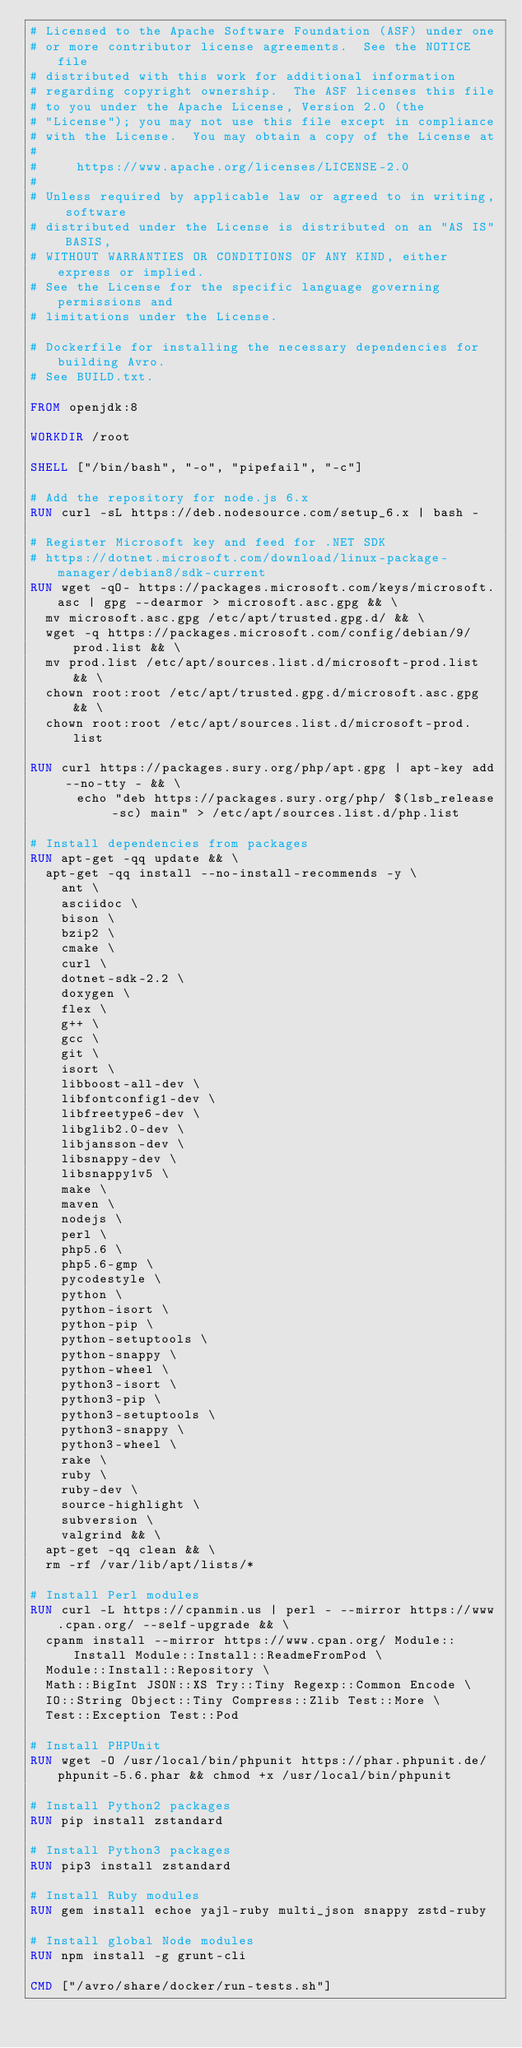<code> <loc_0><loc_0><loc_500><loc_500><_Dockerfile_># Licensed to the Apache Software Foundation (ASF) under one
# or more contributor license agreements.  See the NOTICE file
# distributed with this work for additional information
# regarding copyright ownership.  The ASF licenses this file
# to you under the Apache License, Version 2.0 (the
# "License"); you may not use this file except in compliance
# with the License.  You may obtain a copy of the License at
#
#     https://www.apache.org/licenses/LICENSE-2.0
#
# Unless required by applicable law or agreed to in writing, software
# distributed under the License is distributed on an "AS IS" BASIS,
# WITHOUT WARRANTIES OR CONDITIONS OF ANY KIND, either express or implied.
# See the License for the specific language governing permissions and
# limitations under the License.

# Dockerfile for installing the necessary dependencies for building Avro.
# See BUILD.txt.

FROM openjdk:8

WORKDIR /root

SHELL ["/bin/bash", "-o", "pipefail", "-c"]

# Add the repository for node.js 6.x
RUN curl -sL https://deb.nodesource.com/setup_6.x | bash -

# Register Microsoft key and feed for .NET SDK
# https://dotnet.microsoft.com/download/linux-package-manager/debian8/sdk-current
RUN wget -qO- https://packages.microsoft.com/keys/microsoft.asc | gpg --dearmor > microsoft.asc.gpg && \
  mv microsoft.asc.gpg /etc/apt/trusted.gpg.d/ && \
  wget -q https://packages.microsoft.com/config/debian/9/prod.list && \
  mv prod.list /etc/apt/sources.list.d/microsoft-prod.list && \
  chown root:root /etc/apt/trusted.gpg.d/microsoft.asc.gpg && \
  chown root:root /etc/apt/sources.list.d/microsoft-prod.list

RUN curl https://packages.sury.org/php/apt.gpg | apt-key add --no-tty - && \
      echo "deb https://packages.sury.org/php/ $(lsb_release -sc) main" > /etc/apt/sources.list.d/php.list

# Install dependencies from packages
RUN apt-get -qq update && \
  apt-get -qq install --no-install-recommends -y \
    ant \
    asciidoc \
    bison \
    bzip2 \
    cmake \
    curl \
    dotnet-sdk-2.2 \
    doxygen \
    flex \
    g++ \
    gcc \
    git \
    isort \
    libboost-all-dev \
    libfontconfig1-dev \
    libfreetype6-dev \
    libglib2.0-dev \
    libjansson-dev \
    libsnappy-dev \
    libsnappy1v5 \
    make \
    maven \
    nodejs \
    perl \
    php5.6 \
    php5.6-gmp \
    pycodestyle \
    python \
    python-isort \
    python-pip \
    python-setuptools \
    python-snappy \
    python-wheel \
    python3-isort \
    python3-pip \
    python3-setuptools \
    python3-snappy \
    python3-wheel \
    rake \
    ruby \
    ruby-dev \
    source-highlight \
    subversion \
    valgrind && \
  apt-get -qq clean && \
  rm -rf /var/lib/apt/lists/*

# Install Perl modules
RUN curl -L https://cpanmin.us | perl - --mirror https://www.cpan.org/ --self-upgrade && \
  cpanm install --mirror https://www.cpan.org/ Module::Install Module::Install::ReadmeFromPod \
  Module::Install::Repository \
  Math::BigInt JSON::XS Try::Tiny Regexp::Common Encode \
  IO::String Object::Tiny Compress::Zlib Test::More \
  Test::Exception Test::Pod

# Install PHPUnit
RUN wget -O /usr/local/bin/phpunit https://phar.phpunit.de/phpunit-5.6.phar && chmod +x /usr/local/bin/phpunit

# Install Python2 packages
RUN pip install zstandard

# Install Python3 packages
RUN pip3 install zstandard

# Install Ruby modules
RUN gem install echoe yajl-ruby multi_json snappy zstd-ruby

# Install global Node modules
RUN npm install -g grunt-cli

CMD ["/avro/share/docker/run-tests.sh"]
</code> 